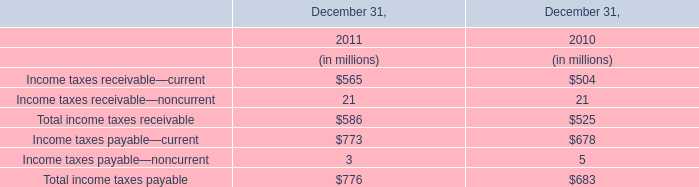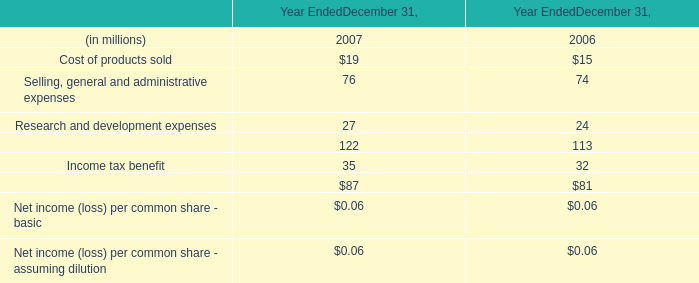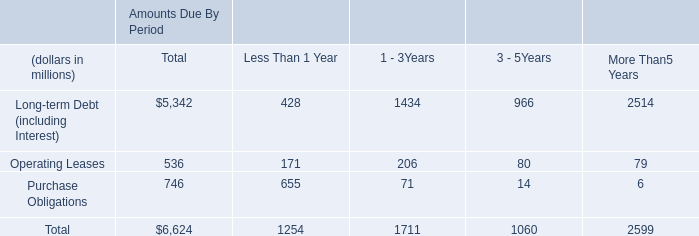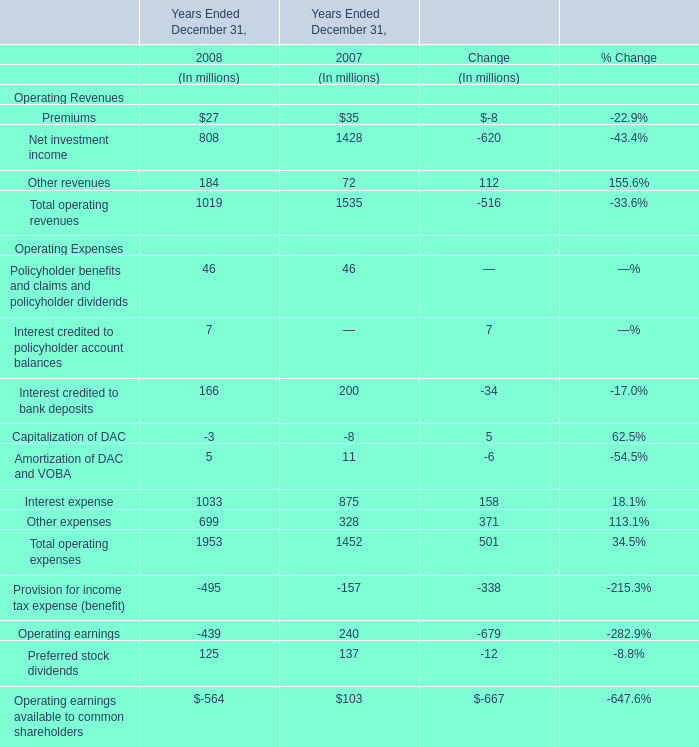In what Year Ended December 31 is Operating earnings positive? 
Answer: 2007. 